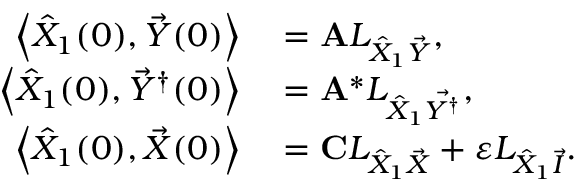<formula> <loc_0><loc_0><loc_500><loc_500>\begin{array} { r l } { \left \langle \hat { X } _ { 1 } ( 0 ) , \vec { Y } ( 0 ) \right \rangle } & = A L _ { \hat { X } _ { 1 } \vec { Y } } , } \\ { \left \langle \hat { X } _ { 1 } ( 0 ) , \vec { Y } ^ { \dagger } ( 0 ) \right \rangle } & = A ^ { * } L _ { \hat { X } _ { 1 } \vec { Y ^ { \dagger } } } , } \\ { \left \langle \hat { X } _ { 1 } ( 0 ) , \vec { X } ( 0 ) \right \rangle } & = C L _ { \hat { X } _ { 1 } \vec { X } } + \varepsilon L _ { \hat { X } _ { 1 } \vec { I } } . } \end{array}</formula> 